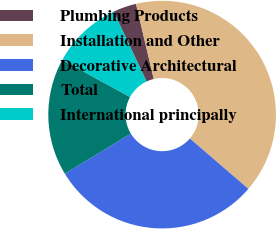Convert chart. <chart><loc_0><loc_0><loc_500><loc_500><pie_chart><fcel>Plumbing Products<fcel>Installation and Other<fcel>Decorative Architectural<fcel>Total<fcel>International principally<nl><fcel>3.33%<fcel>40.0%<fcel>30.0%<fcel>16.67%<fcel>10.0%<nl></chart> 